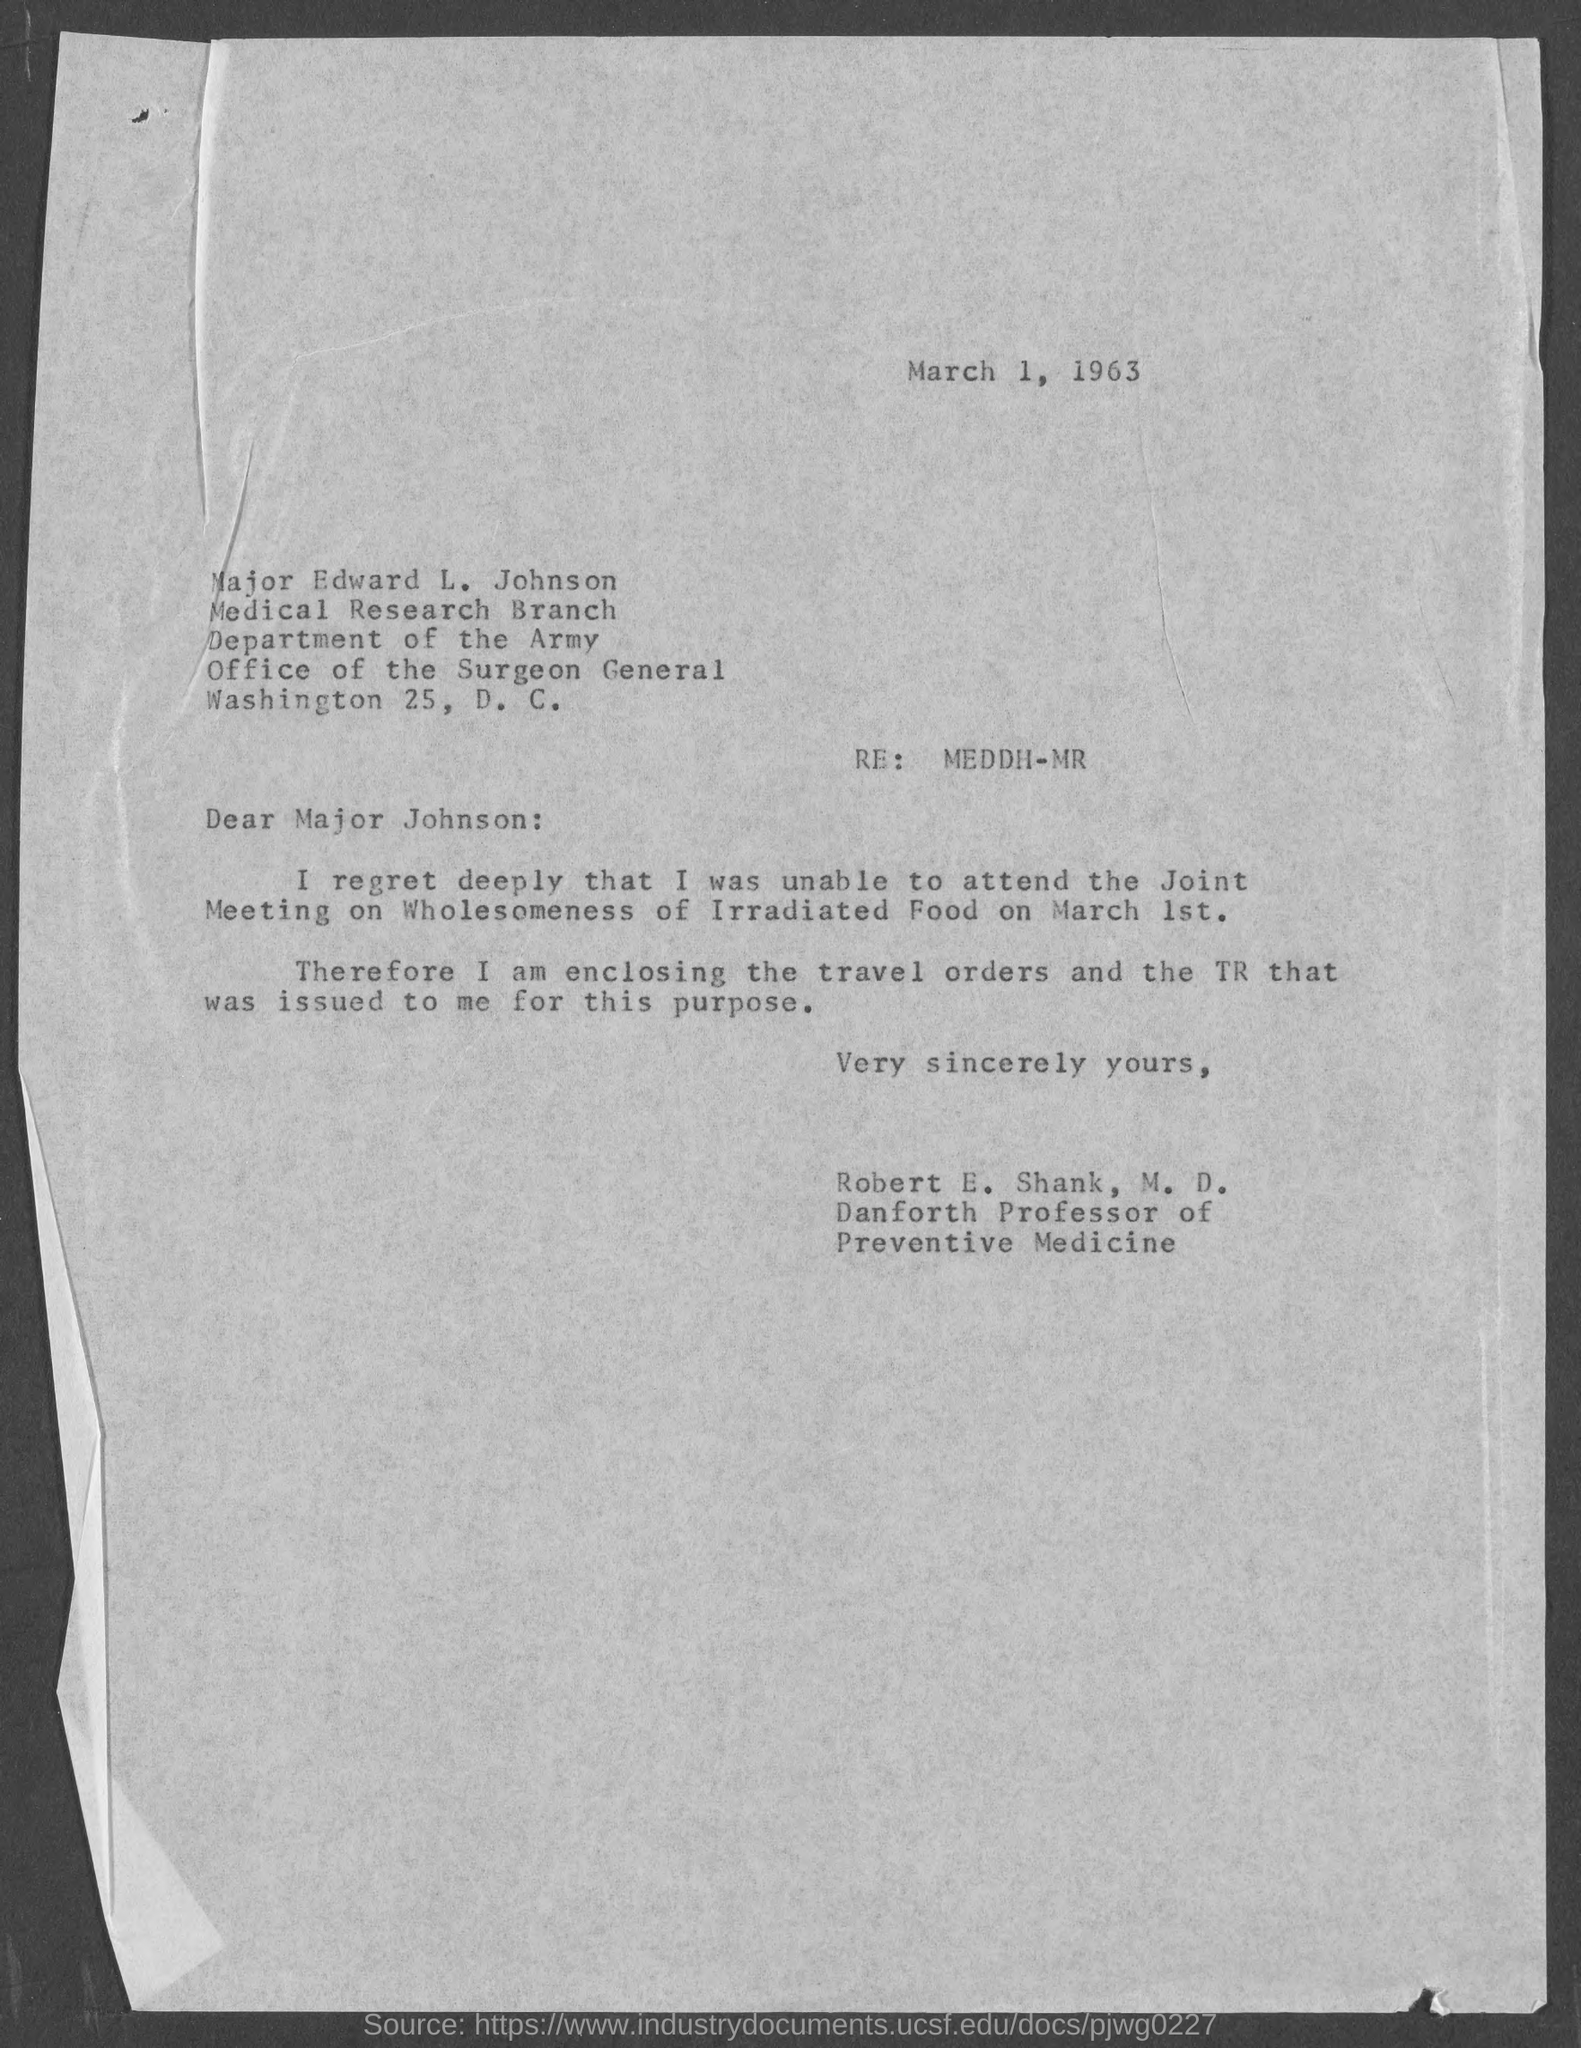Outline some significant characteristics in this image. The date mentioned at the top of the document is March 1, 1963. The memorandum is addressed to Major Johnson. 